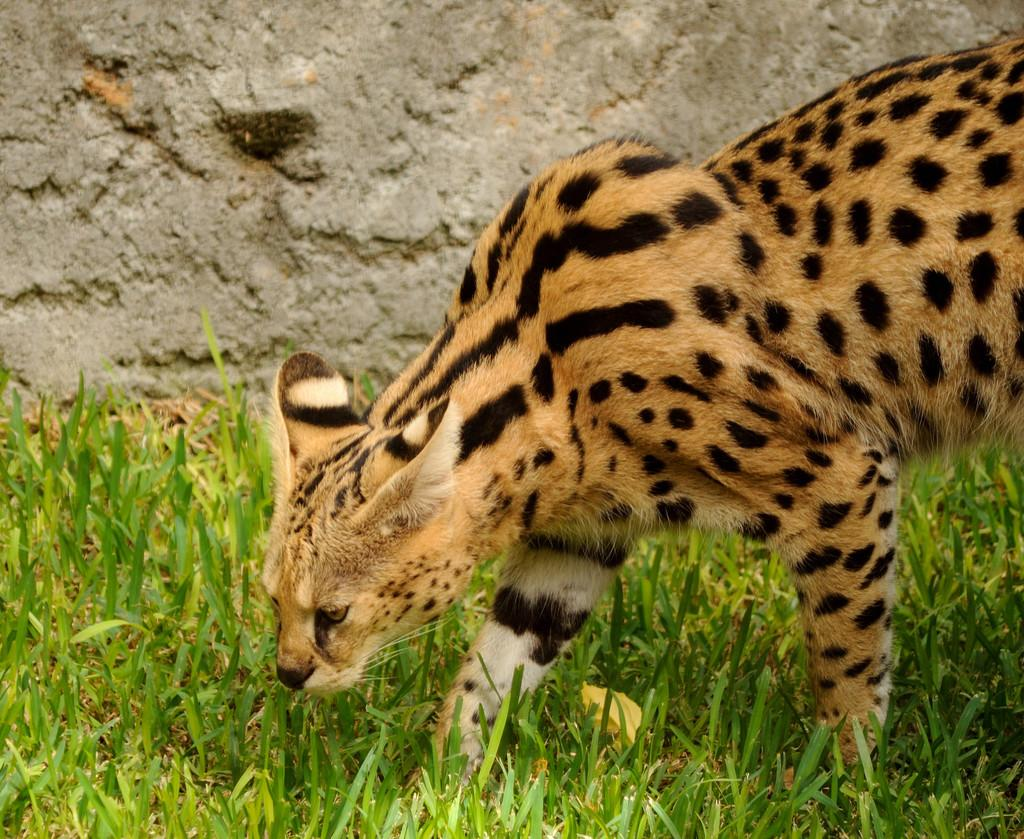What type of animal is in the image? There is a leopard in the image. What type of vegetation can be seen in the image? There is grass visible in the image. What type of structure is in the image? There is a wall in the image. How many birds are sitting on the ant in the image? There are no birds or ants present in the image. 